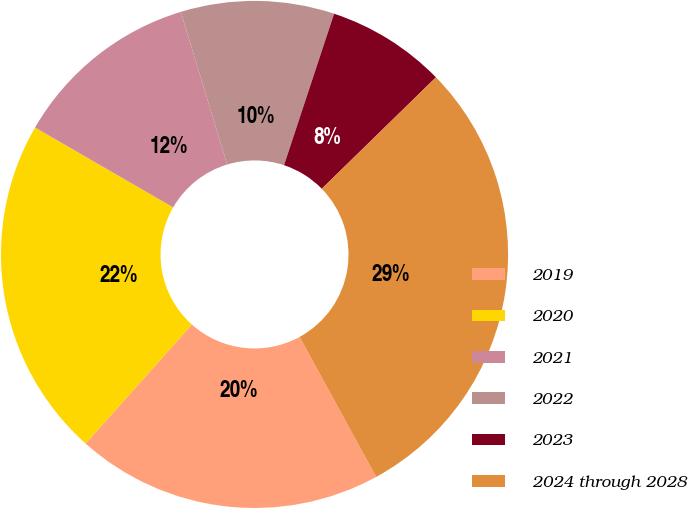Convert chart to OTSL. <chart><loc_0><loc_0><loc_500><loc_500><pie_chart><fcel>2019<fcel>2020<fcel>2021<fcel>2022<fcel>2023<fcel>2024 through 2028<nl><fcel>19.57%<fcel>21.74%<fcel>11.96%<fcel>9.78%<fcel>7.61%<fcel>29.35%<nl></chart> 